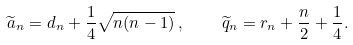<formula> <loc_0><loc_0><loc_500><loc_500>\widetilde { a } _ { n } = d _ { n } + \frac { 1 } { 4 } \sqrt { n ( n - 1 ) } \, , \quad \widetilde { q } _ { n } = r _ { n } + \frac { n } { 2 } + \frac { 1 } { 4 } .</formula> 